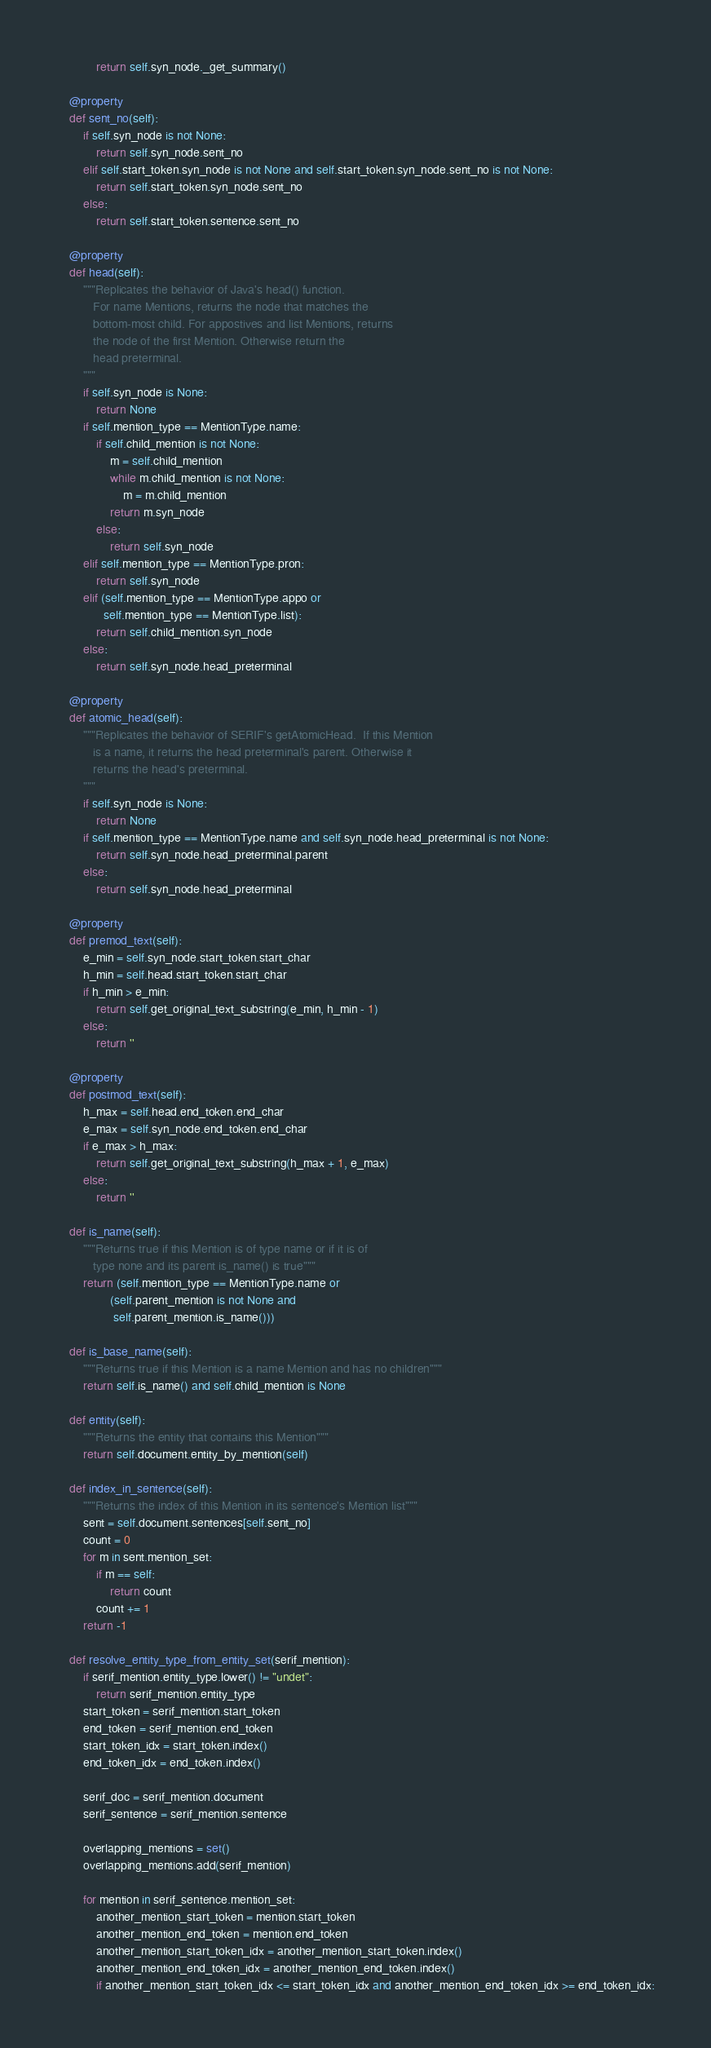Convert code to text. <code><loc_0><loc_0><loc_500><loc_500><_Python_>            return self.syn_node._get_summary()

    @property
    def sent_no(self):
        if self.syn_node is not None:
            return self.syn_node.sent_no
        elif self.start_token.syn_node is not None and self.start_token.syn_node.sent_no is not None:
            return self.start_token.syn_node.sent_no
        else:
            return self.start_token.sentence.sent_no

    @property
    def head(self):
        """Replicates the behavior of Java's head() function.
           For name Mentions, returns the node that matches the
           bottom-most child. For appostives and list Mentions, returns
           the node of the first Mention. Otherwise return the
           head preterminal.
        """
        if self.syn_node is None:
            return None
        if self.mention_type == MentionType.name:
            if self.child_mention is not None:
                m = self.child_mention
                while m.child_mention is not None:
                    m = m.child_mention
                return m.syn_node
            else:
                return self.syn_node
        elif self.mention_type == MentionType.pron:
            return self.syn_node
        elif (self.mention_type == MentionType.appo or
              self.mention_type == MentionType.list):
            return self.child_mention.syn_node
        else:
            return self.syn_node.head_preterminal

    @property
    def atomic_head(self):
        """Replicates the behavior of SERIF's getAtomicHead.  If this Mention
           is a name, it returns the head preterminal's parent. Otherwise it
           returns the head's preterminal.
        """
        if self.syn_node is None:
            return None
        if self.mention_type == MentionType.name and self.syn_node.head_preterminal is not None:
            return self.syn_node.head_preterminal.parent
        else:
            return self.syn_node.head_preterminal

    @property
    def premod_text(self):
        e_min = self.syn_node.start_token.start_char
        h_min = self.head.start_token.start_char
        if h_min > e_min:
            return self.get_original_text_substring(e_min, h_min - 1)
        else:
            return ''

    @property
    def postmod_text(self):
        h_max = self.head.end_token.end_char
        e_max = self.syn_node.end_token.end_char
        if e_max > h_max:
            return self.get_original_text_substring(h_max + 1, e_max)
        else:
            return ''

    def is_name(self):
        """Returns true if this Mention is of type name or if it is of
           type none and its parent is_name() is true"""
        return (self.mention_type == MentionType.name or
                (self.parent_mention is not None and
                 self.parent_mention.is_name()))

    def is_base_name(self):
        """Returns true if this Mention is a name Mention and has no children"""
        return self.is_name() and self.child_mention is None

    def entity(self):
        """Returns the entity that contains this Mention"""
        return self.document.entity_by_mention(self)

    def index_in_sentence(self):
        """Returns the index of this Mention in its sentence's Mention list"""
        sent = self.document.sentences[self.sent_no]
        count = 0
        for m in sent.mention_set:
            if m == self:
                return count
            count += 1
        return -1

    def resolve_entity_type_from_entity_set(serif_mention):
        if serif_mention.entity_type.lower() != "undet":
            return serif_mention.entity_type
        start_token = serif_mention.start_token
        end_token = serif_mention.end_token
        start_token_idx = start_token.index()
        end_token_idx = end_token.index()

        serif_doc = serif_mention.document
        serif_sentence = serif_mention.sentence

        overlapping_mentions = set()
        overlapping_mentions.add(serif_mention)

        for mention in serif_sentence.mention_set:
            another_mention_start_token = mention.start_token
            another_mention_end_token = mention.end_token
            another_mention_start_token_idx = another_mention_start_token.index()
            another_mention_end_token_idx = another_mention_end_token.index()
            if another_mention_start_token_idx <= start_token_idx and another_mention_end_token_idx >= end_token_idx:</code> 